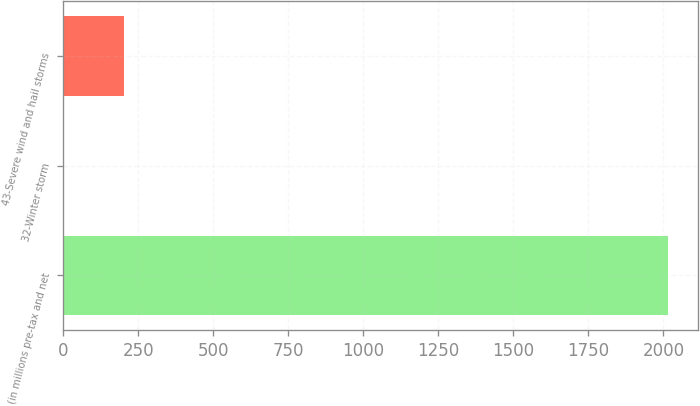Convert chart to OTSL. <chart><loc_0><loc_0><loc_500><loc_500><bar_chart><fcel>(in millions pre-tax and net<fcel>32-Winter storm<fcel>43-Severe wind and hail storms<nl><fcel>2016<fcel>1<fcel>202.5<nl></chart> 